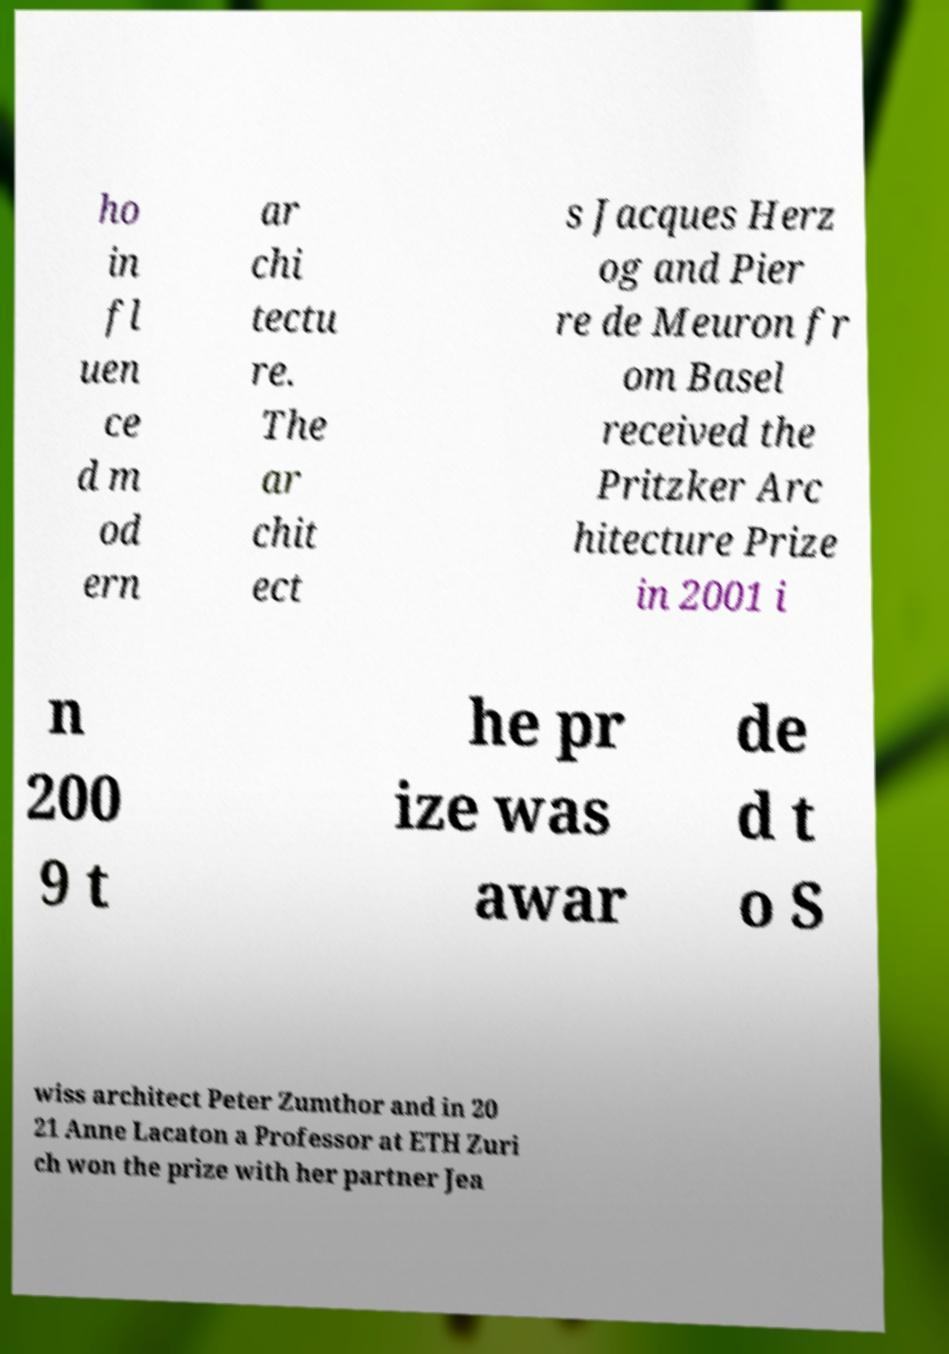Can you read and provide the text displayed in the image?This photo seems to have some interesting text. Can you extract and type it out for me? ho in fl uen ce d m od ern ar chi tectu re. The ar chit ect s Jacques Herz og and Pier re de Meuron fr om Basel received the Pritzker Arc hitecture Prize in 2001 i n 200 9 t he pr ize was awar de d t o S wiss architect Peter Zumthor and in 20 21 Anne Lacaton a Professor at ETH Zuri ch won the prize with her partner Jea 